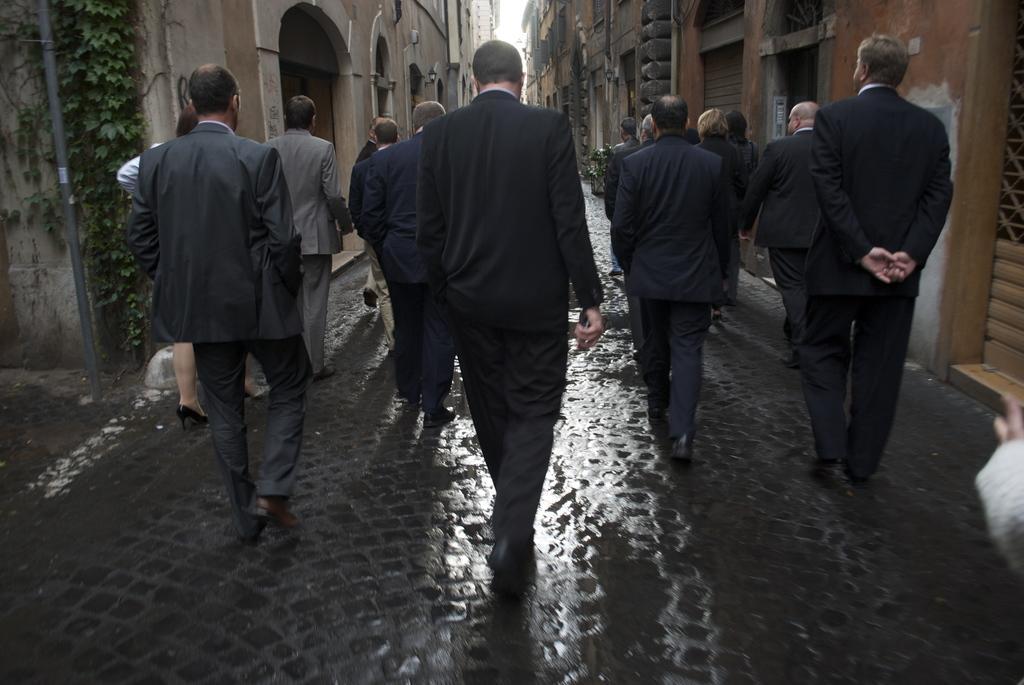In one or two sentences, can you explain what this image depicts? This picture is clicked outside. In the center we can see the group of people wearing suits and walking on the ground. On the right we can see the buildings. On the left and there is a pole, leaves and the buildings. In the background there is a sky. 